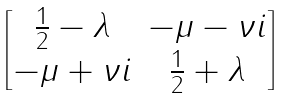Convert formula to latex. <formula><loc_0><loc_0><loc_500><loc_500>\begin{bmatrix} \frac { 1 } { 2 } - \lambda & - \mu - \nu i \\ - \mu + \nu i & \frac { 1 } { 2 } + \lambda \end{bmatrix}</formula> 